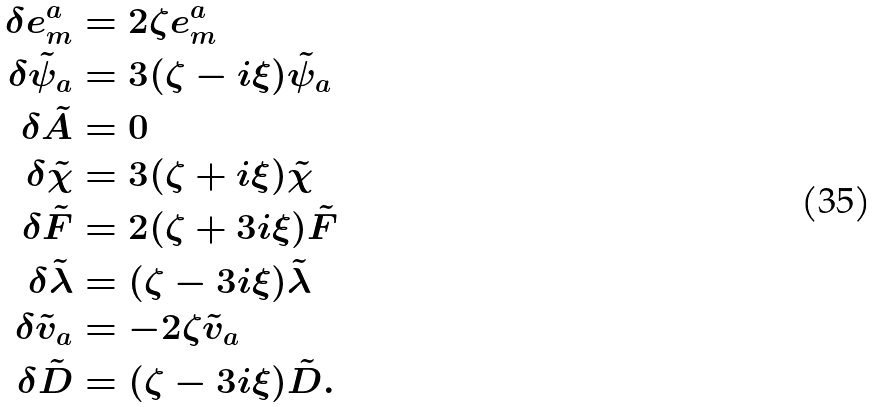<formula> <loc_0><loc_0><loc_500><loc_500>\delta e ^ { a } _ { m } & = 2 \zeta e ^ { a } _ { m } \\ \delta \tilde { \psi } _ { a } & = 3 ( \zeta - i \xi ) \tilde { \psi } _ { a } \\ \delta \tilde { A } & = 0 \\ \delta \tilde { \chi } & = 3 ( \zeta + i \xi ) \tilde { \chi } \\ \delta \tilde { F } & = 2 ( \zeta + 3 i \xi ) \tilde { F } \\ \delta \tilde { \lambda } & = ( \zeta - 3 i \xi ) \tilde { \lambda } \\ \delta \tilde { v } _ { a } & = - 2 \zeta \tilde { v } _ { a } \\ \delta \tilde { D } & = ( \zeta - 3 i \xi ) \tilde { D } .</formula> 